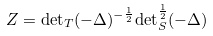<formula> <loc_0><loc_0><loc_500><loc_500>Z = { \det } _ { T } ( - \Delta ) ^ { - \frac { 1 } { 2 } } { \det } _ { S } ^ { \frac { 1 } { 2 } } ( - \Delta )</formula> 